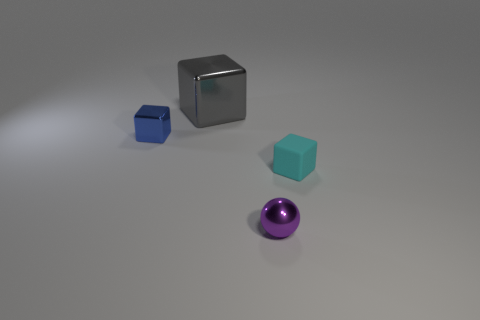Can you tell me what material the objects in the image are made from? The objects appear to have different materials. The cyan and silver cubes show reflective surfaces that suggest they might be made of metal. The purple sphere has a slightly matte finish which could indicate a plastic or rubber material. 